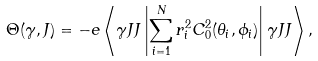Convert formula to latex. <formula><loc_0><loc_0><loc_500><loc_500>\Theta ( \gamma , J ) = - e \left \langle \gamma J J \left | \sum _ { i = 1 } ^ { N } r _ { i } ^ { 2 } C ^ { 2 } _ { 0 } ( \theta _ { i } , \phi _ { i } ) \right | \gamma J J \right \rangle ,</formula> 